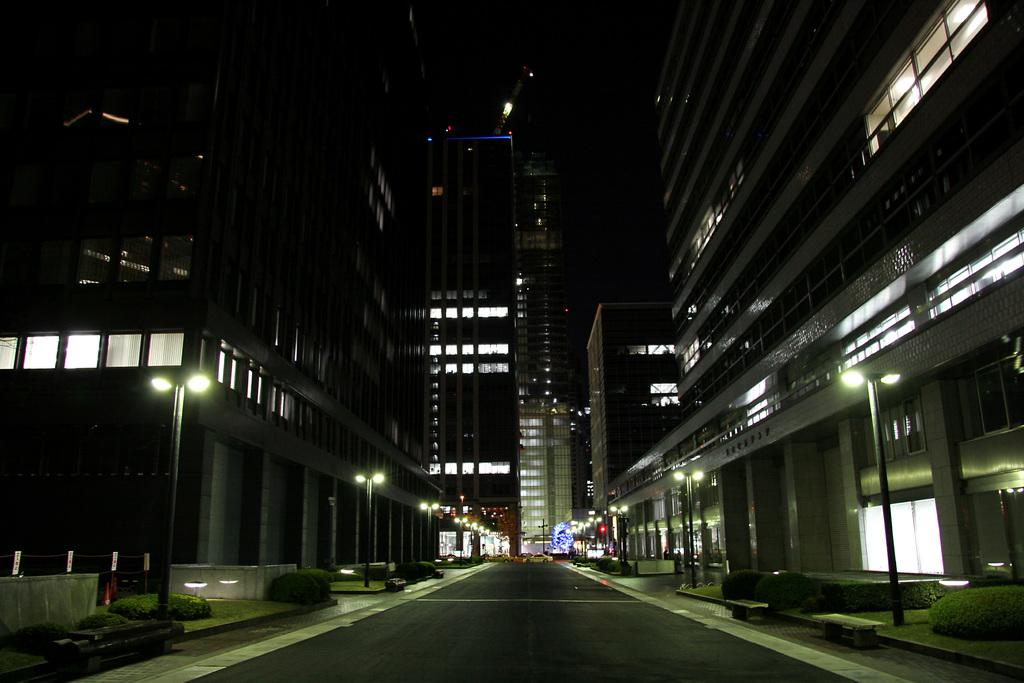What type of structures can be seen in the image? There are buildings with windows in the image. What are the vertical structures along the pathway? There are street poles in the image. What can be used for walking or traveling in the image? There is a pathway in the image. What are the sources of illumination in the image? There are lights in the image. What type of vegetation is present in the image? There are plants in the image. What is visible above the structures and vegetation? The sky is visible in the image. How does the payment system work for the plants in the image? There is no payment system for the plants in the image; they are not for sale. What type of eye can be seen on the street poles in the image? There are no eyes present on the street poles or any other objects in the image. 